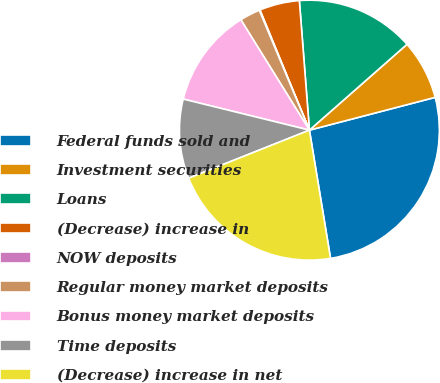Convert chart. <chart><loc_0><loc_0><loc_500><loc_500><pie_chart><fcel>Federal funds sold and<fcel>Investment securities<fcel>Loans<fcel>(Decrease) increase in<fcel>NOW deposits<fcel>Regular money market deposits<fcel>Bonus money market deposits<fcel>Time deposits<fcel>(Decrease) increase in net<nl><fcel>26.46%<fcel>7.42%<fcel>14.75%<fcel>4.98%<fcel>0.09%<fcel>2.54%<fcel>12.31%<fcel>9.87%<fcel>21.57%<nl></chart> 